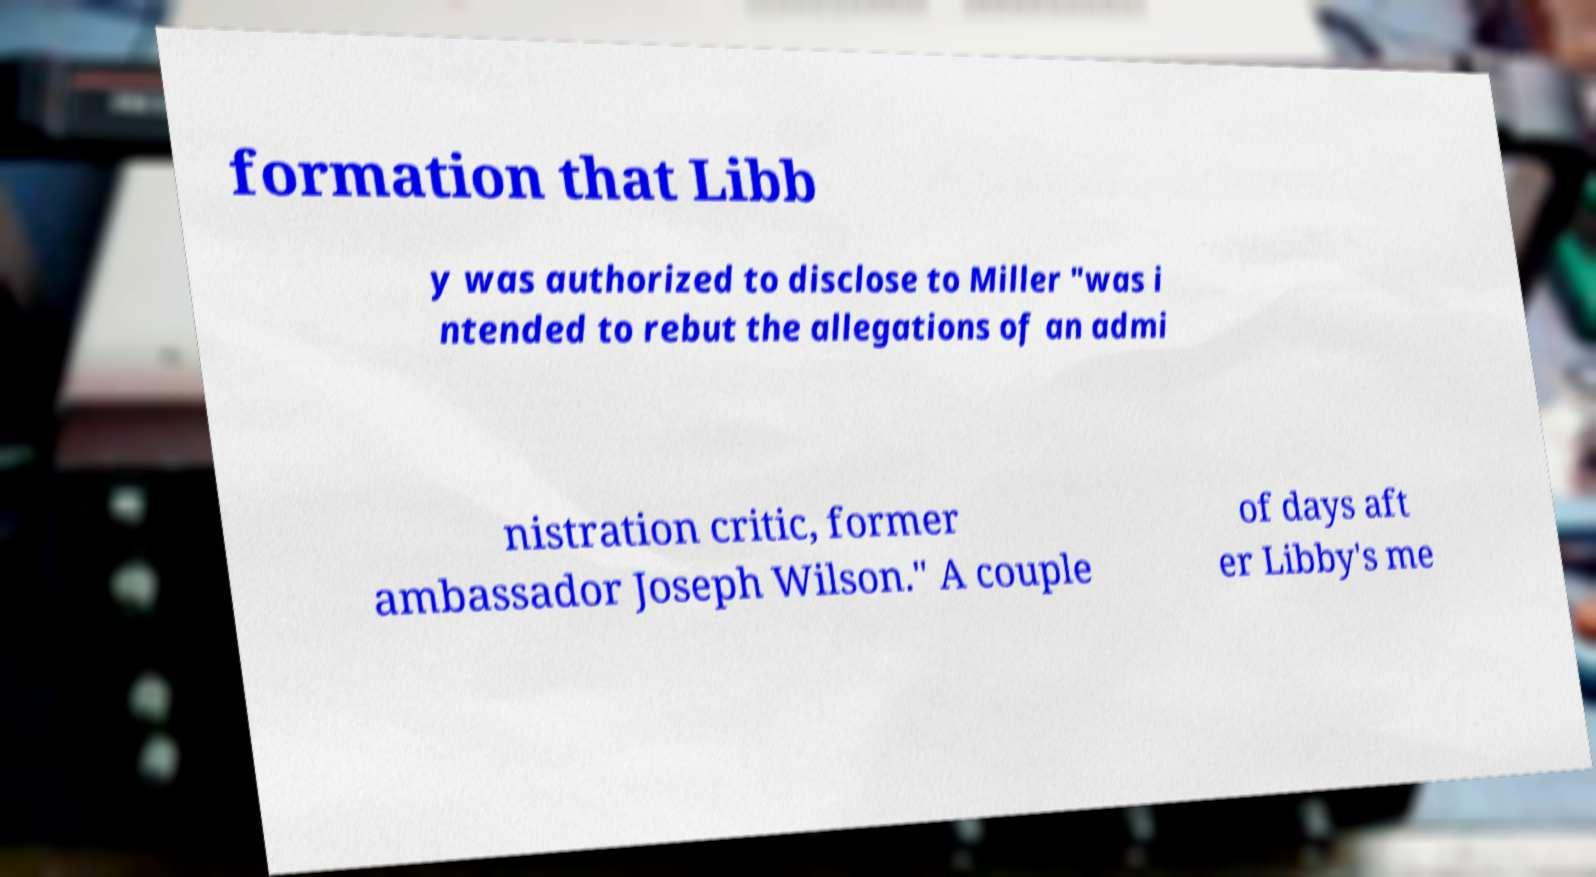Please read and relay the text visible in this image. What does it say? formation that Libb y was authorized to disclose to Miller "was i ntended to rebut the allegations of an admi nistration critic, former ambassador Joseph Wilson." A couple of days aft er Libby's me 